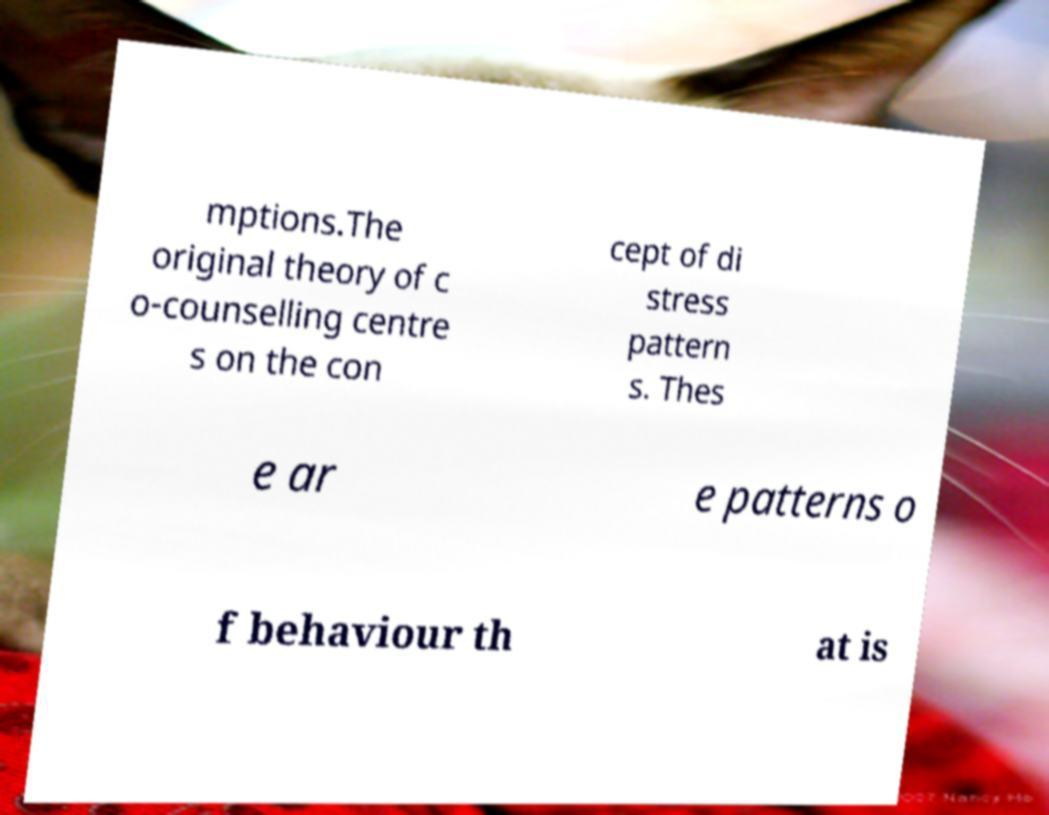Can you read and provide the text displayed in the image?This photo seems to have some interesting text. Can you extract and type it out for me? mptions.The original theory of c o-counselling centre s on the con cept of di stress pattern s. Thes e ar e patterns o f behaviour th at is 